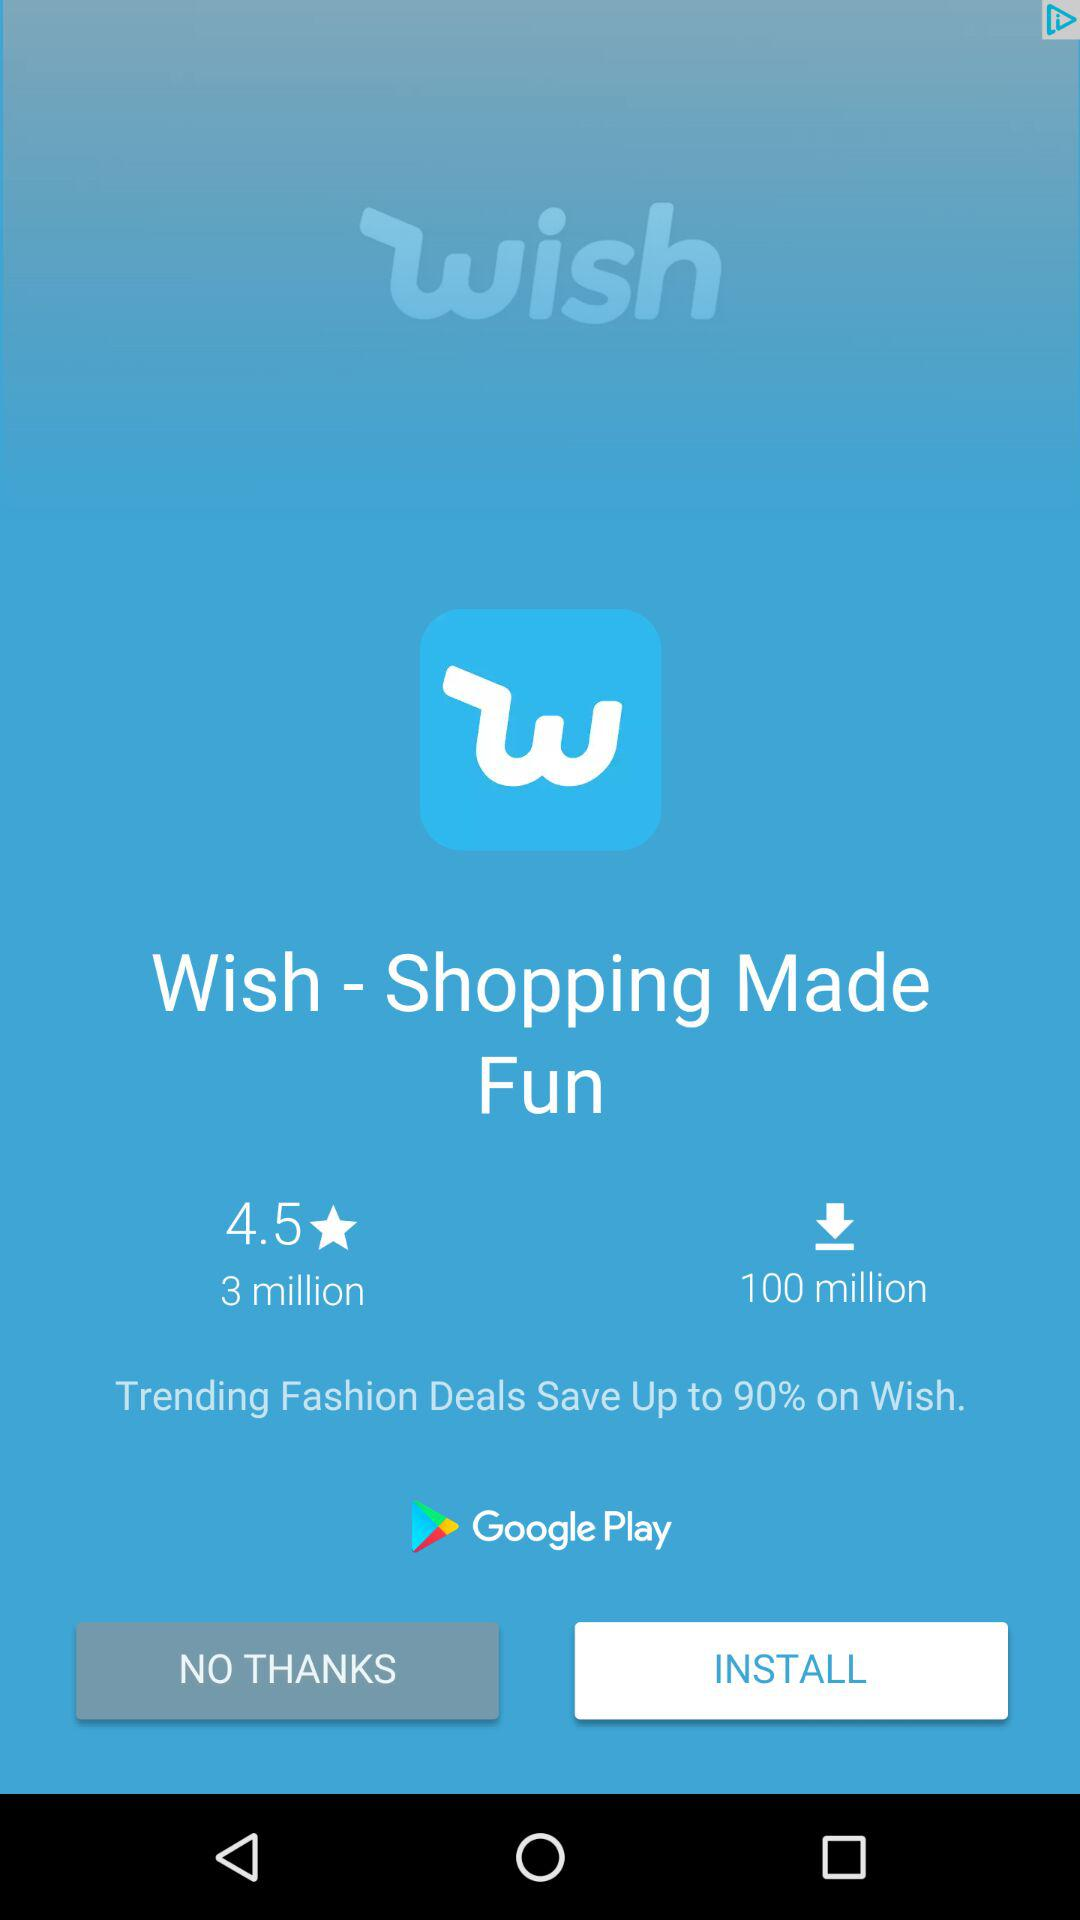How many more downloads does Wish have than reviews?
Answer the question using a single word or phrase. 97 million 